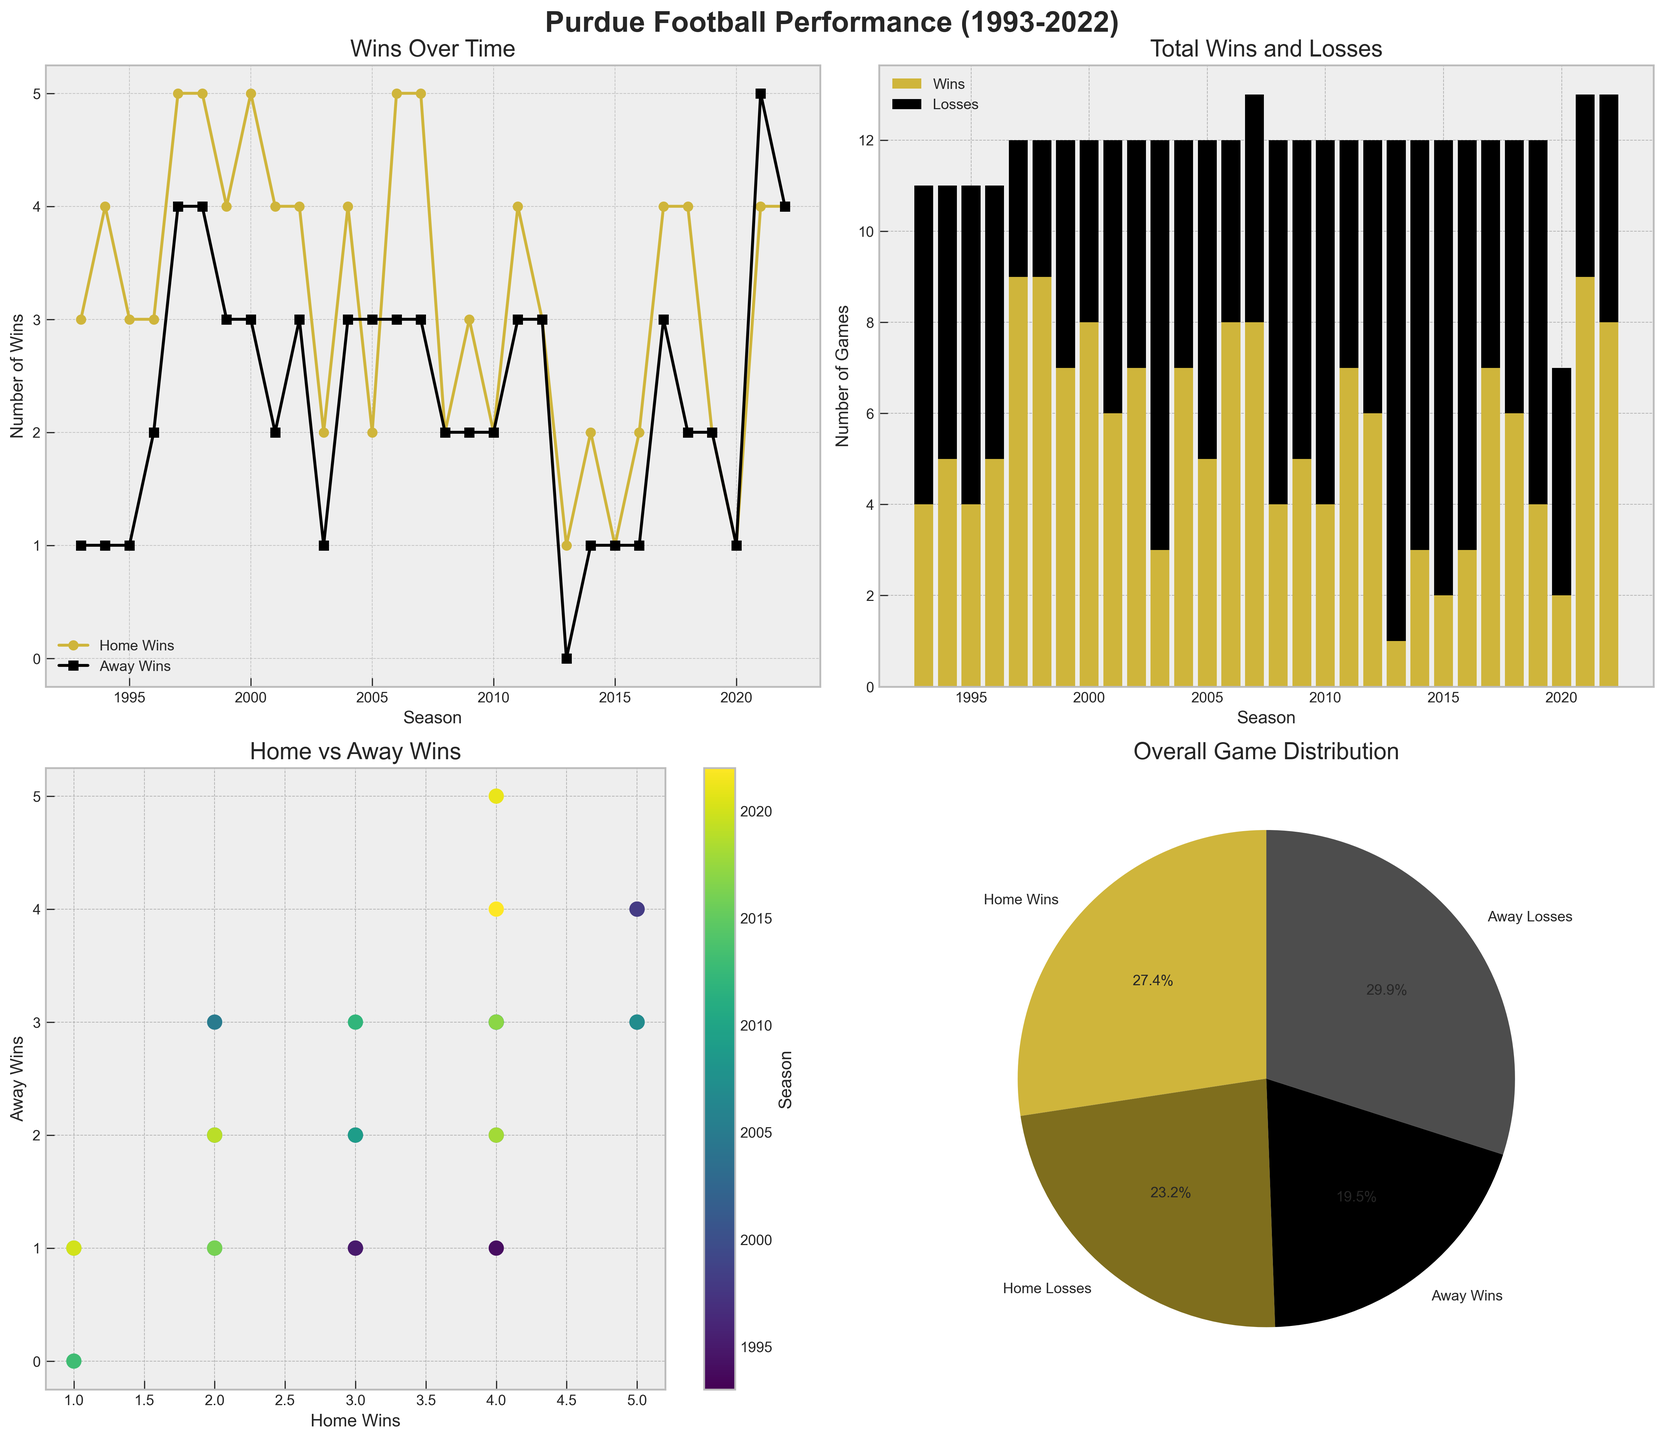What season had the highest number of home wins? Refer to the first subplot, the peak of the yellow line (home wins) corresponds to the seasons 2000, 2006, and 2007 with 5 wins. Check each of these seasons to find the highest value.
Answer: 2000, 2006, and 2007 How many total wins were recorded in the 1997 season? The first subplot shows 5 home wins and 4 away wins in 1997. Adding these successes results in 5 + 4.
Answer: 9 What percentage of total games were home losses? Refer to the pie chart for total counts. Calculate the percentage using home losses divided by total games. Home losses = 86; Total games = 173+86+61+113=433; (86/433)*100
Answer: ~19.9% Which years had at least 4 away wins? The first subplot with black squares shows away wins. Check seasonal data to find the years with 4 or more away wins. 1997, 1998, 2021, 2022 fit this criterion.
Answer: 1997, 1998, 2021, 2022 How does the number of home wins compare to away wins in 2005? Observe the first subplot for 2005; home wins are indicated by the yellow line and away by the black squares. Home wins = 2; Away wins = 3; Compare these values.
Answer: Fewer home wins In which seasons did Purdue have equal numbers of home and away losses? Using the first and second subplots, find seasons where home losses match away losses. Notably, 2002, 2004, 2005, 2012, and 2017 showcase equal losses at home and away.
Answer: 2002, 2004, 2005, 2012, 2017 What is the trend of total wins over time? Refer to the second subplot, where the total wins (gold bars) either rise, fall, or remain stable. Observe any consistent patterns. Overall, the trend appears inconsistent without a clear steady increase or decrease.
Answer: Inconsistent How many seasons had more wins than losses? From the second subplot, compare gold bars for wins and black bars for losses across each season. Count occurrences where wins exceed losses.
Answer: 10 seasons (1997, 1998, 2000, 2002, 2004, 2006, 2007, 2011, 2017, 2021) How did Purdue's performance vary in home and away games? Assess the stacked bar chart. Occasionally, substantial discrepancies exist, but in other instances, the results are fairly balanced.
Answer: Varied greatly What pattern of wins and losses did Purdue exhibit in the scattering data? The scatter plot in the third subplot shows correlation: low numbering in both domains signifies mediocre performance, whereas higher clustering suggests improved symmetry in wins and losses.
Answer: Varied correlation 